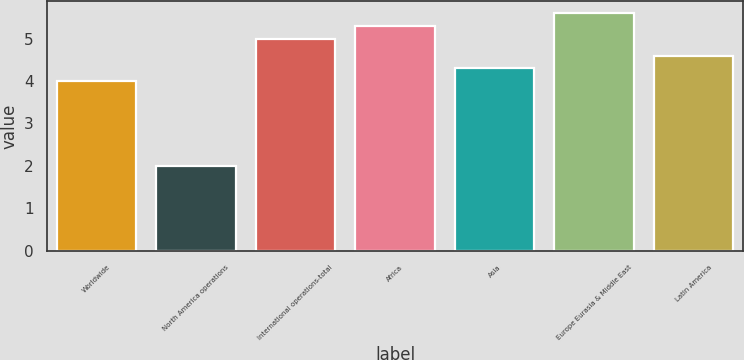<chart> <loc_0><loc_0><loc_500><loc_500><bar_chart><fcel>Worldwide<fcel>North America operations<fcel>International operations-total<fcel>Africa<fcel>Asia<fcel>Europe Eurasia & Middle East<fcel>Latin America<nl><fcel>4<fcel>2<fcel>5<fcel>5.3<fcel>4.3<fcel>5.6<fcel>4.6<nl></chart> 